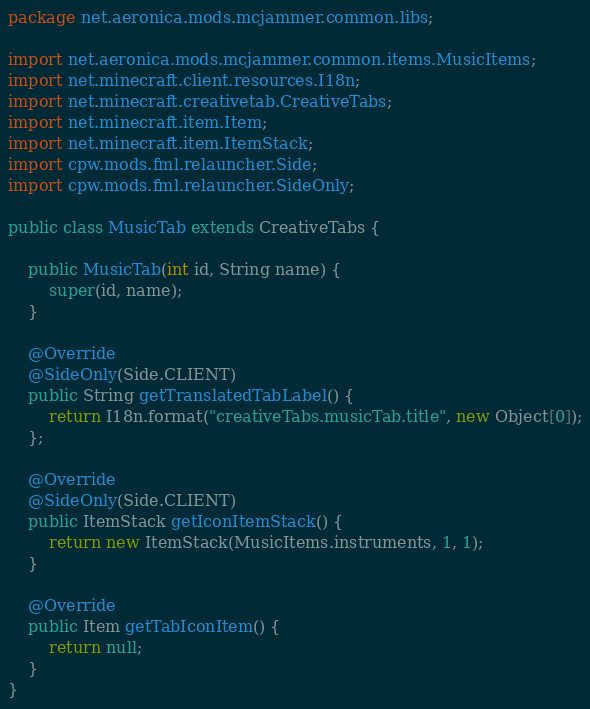<code> <loc_0><loc_0><loc_500><loc_500><_Java_>package net.aeronica.mods.mcjammer.common.libs;

import net.aeronica.mods.mcjammer.common.items.MusicItems;
import net.minecraft.client.resources.I18n;
import net.minecraft.creativetab.CreativeTabs;
import net.minecraft.item.Item;
import net.minecraft.item.ItemStack;
import cpw.mods.fml.relauncher.Side;
import cpw.mods.fml.relauncher.SideOnly;

public class MusicTab extends CreativeTabs {

	public MusicTab(int id, String name) {
		super(id, name);
	}

	@Override
	@SideOnly(Side.CLIENT)
	public String getTranslatedTabLabel() {
		return I18n.format("creativeTabs.musicTab.title", new Object[0]);
	};

	@Override
	@SideOnly(Side.CLIENT)
	public ItemStack getIconItemStack() {
		return new ItemStack(MusicItems.instruments, 1, 1);
	}

	@Override
	public Item getTabIconItem() {
		return null;
	}
}
</code> 